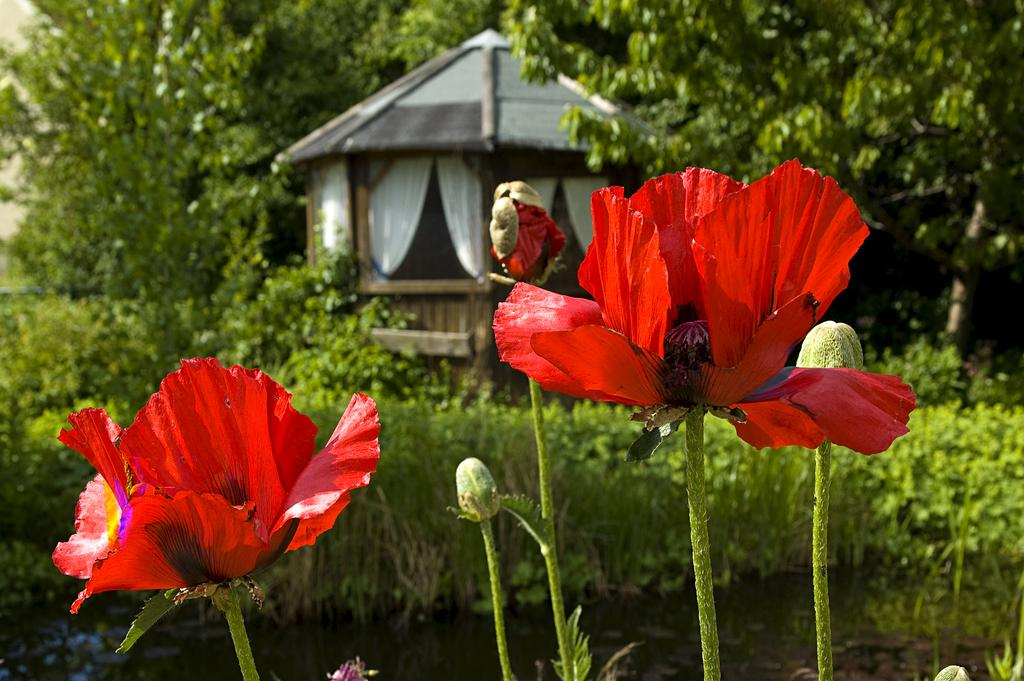What type of vegetation can be seen in the image? There are flowers, buds, plants, and trees in the image. What type of structure is present in the image? There is a house in the image. What type of window treatment is visible in the image? There are curtains in the image. What type of advice can be seen being given in the image? There is no advice being given in the image; it features flowers, buds, plants, trees, a house, and curtains. 